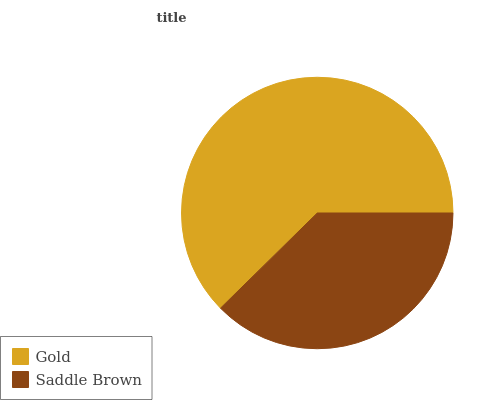Is Saddle Brown the minimum?
Answer yes or no. Yes. Is Gold the maximum?
Answer yes or no. Yes. Is Saddle Brown the maximum?
Answer yes or no. No. Is Gold greater than Saddle Brown?
Answer yes or no. Yes. Is Saddle Brown less than Gold?
Answer yes or no. Yes. Is Saddle Brown greater than Gold?
Answer yes or no. No. Is Gold less than Saddle Brown?
Answer yes or no. No. Is Gold the high median?
Answer yes or no. Yes. Is Saddle Brown the low median?
Answer yes or no. Yes. Is Saddle Brown the high median?
Answer yes or no. No. Is Gold the low median?
Answer yes or no. No. 